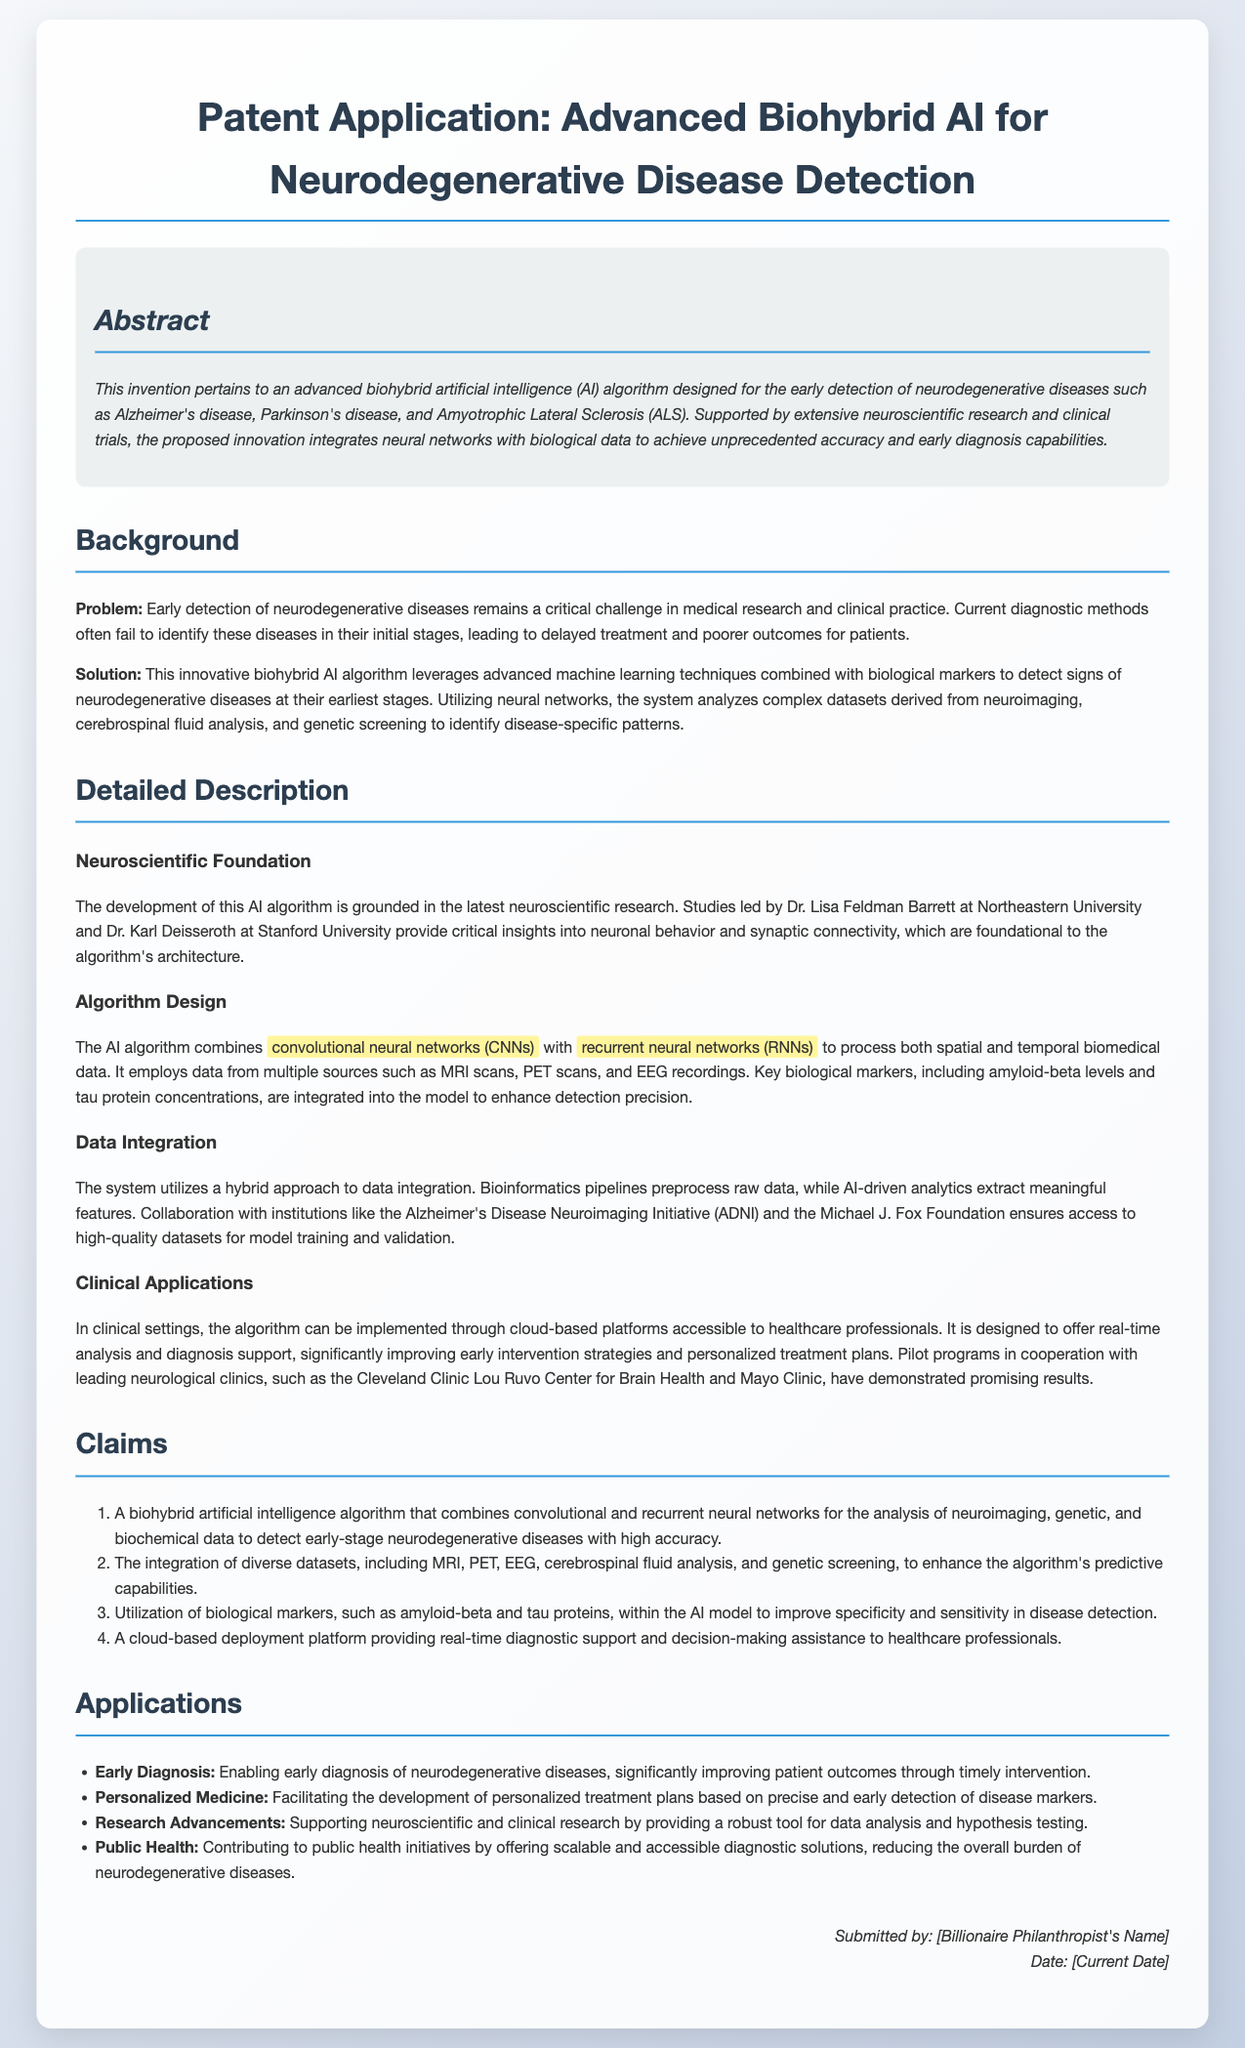What is the main focus of the patent application? The main focus of the patent application is the development of an advanced biohybrid artificial intelligence algorithm for the early detection of neurodegenerative diseases.
Answer: advanced biohybrid AI algorithm for early detection of neurodegenerative diseases Who are the key researchers mentioned in the document? The key researchers mentioned are Dr. Lisa Feldman Barrett and Dr. Karl Deisseroth.
Answer: Dr. Lisa Feldman Barrett and Dr. Karl Deisseroth What types of neural networks are used in the algorithm? The algorithm utilizes convolutional neural networks and recurrent neural networks.
Answer: convolutional neural networks and recurrent neural networks Which biological markers are integrated into the model? The biological markers integrated into the model are amyloid-beta and tau proteins.
Answer: amyloid-beta and tau proteins What is one major application of this AI algorithm? One major application of this AI algorithm is enabling early diagnosis of neurodegenerative diseases.
Answer: enabling early diagnosis of neurodegenerative diseases How does the algorithm improve patient outcomes? The algorithm improves patient outcomes through timely intervention by enabling early diagnosis.
Answer: timely intervention What type of platform is suggested for deploying the algorithm? A cloud-based platform is suggested for deploying the algorithm.
Answer: cloud-based platform What are the ultimate goals of the algorithm according to the document? The ultimate goals include enhancing early diagnosis, personalized medicine, supporting research advancements, and contributing to public health.
Answer: enhancing early diagnosis, personalized medicine, supporting research advancements, and contributing to public health 